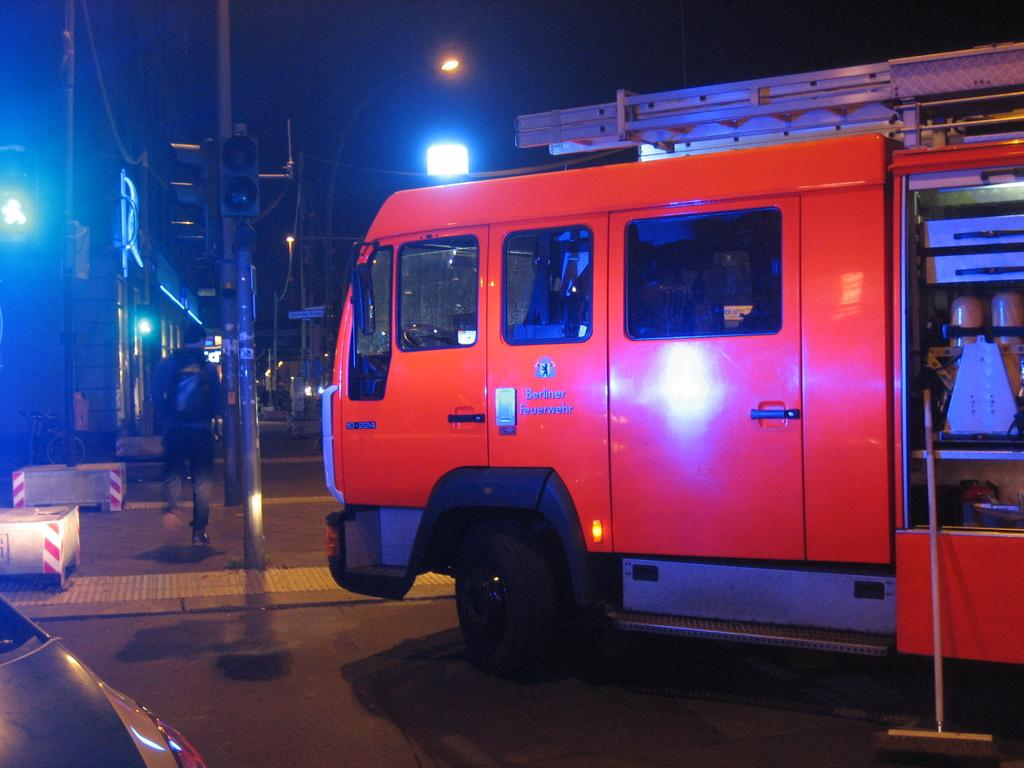What is happening on the road in the image? There are vehicles on the road in the image. Can you describe the interaction between the man and the truck in the image? A man is walking in front of a truck in the image. What type of material is visible in the image? Metal rods are visible in the image. What can be used to illuminate in the image? Lights are present in the image. What type of soap is being used to wash the vehicles in the image? There is no soap or washing activity present in the image; it only shows vehicles on the road, a man walking in front of a truck, metal rods, and lights. What statement is being made by the vehicles in the image? There is no statement being made by the vehicles in the image; they are simply present on the road. 